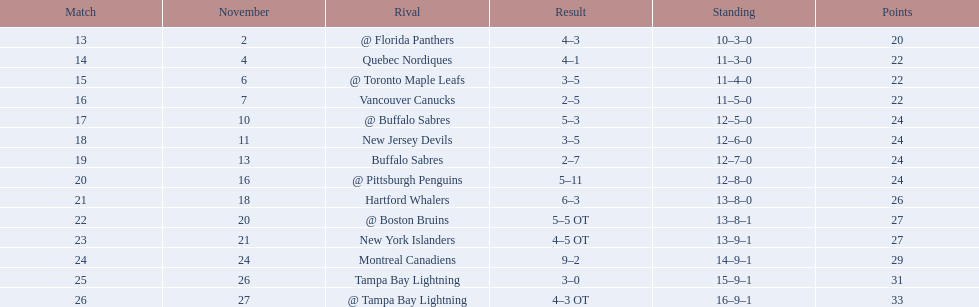Who are all of the teams? @ Florida Panthers, Quebec Nordiques, @ Toronto Maple Leafs, Vancouver Canucks, @ Buffalo Sabres, New Jersey Devils, Buffalo Sabres, @ Pittsburgh Penguins, Hartford Whalers, @ Boston Bruins, New York Islanders, Montreal Canadiens, Tampa Bay Lightning. What games finished in overtime? 22, 23, 26. In game number 23, who did they face? New York Islanders. 